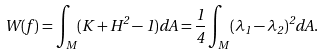<formula> <loc_0><loc_0><loc_500><loc_500>W ( f ) = \int _ { M } ( K + H ^ { 2 } - 1 ) d A = \frac { 1 } { 4 } \int _ { M } ( \lambda _ { 1 } - \lambda _ { 2 } ) ^ { 2 } d A .</formula> 